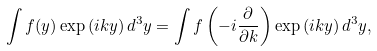<formula> <loc_0><loc_0><loc_500><loc_500>\int f ( y ) \exp \left ( i k y \right ) d ^ { 3 } y = \int f \left ( - i \frac { \partial } { \partial k } \right ) \exp \left ( i k y \right ) d ^ { 3 } y ,</formula> 